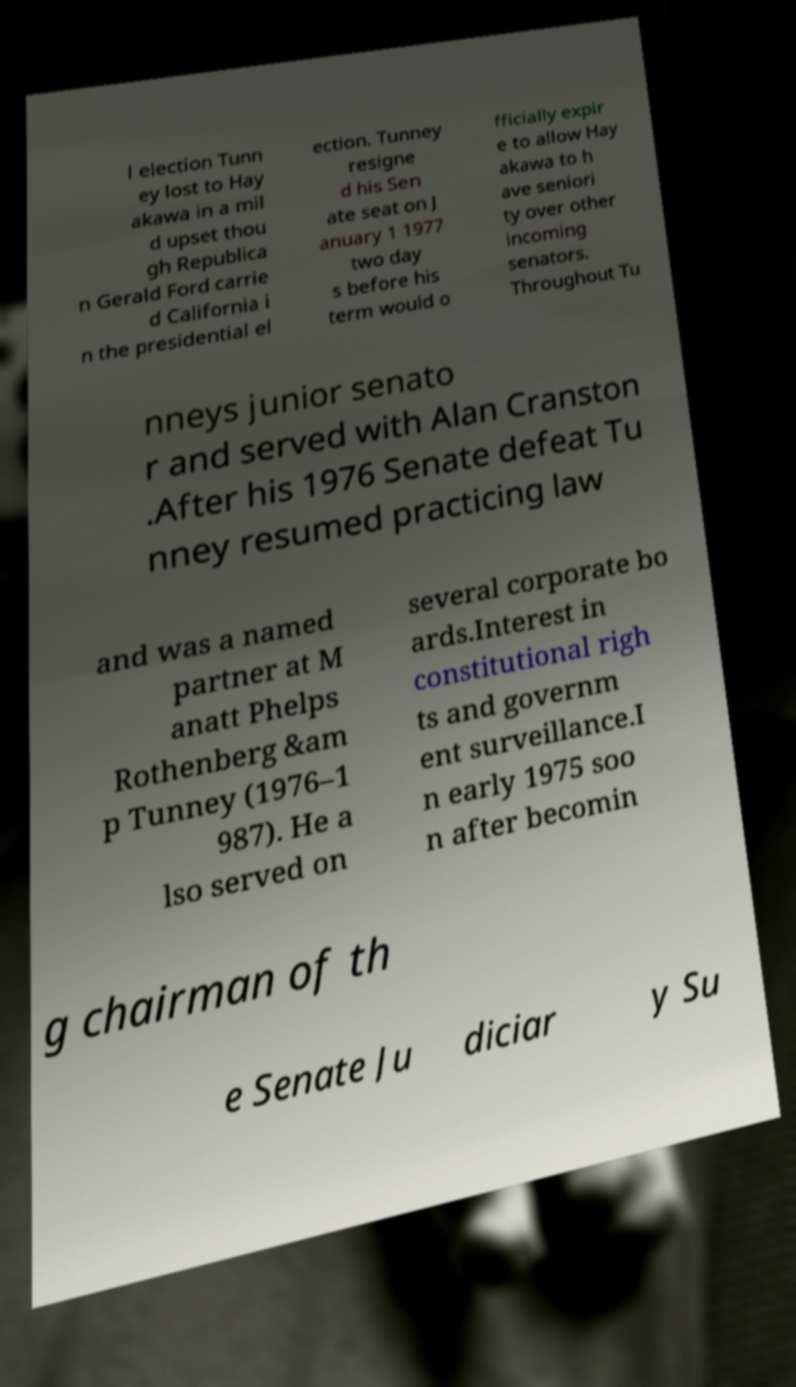I need the written content from this picture converted into text. Can you do that? l election Tunn ey lost to Hay akawa in a mil d upset thou gh Republica n Gerald Ford carrie d California i n the presidential el ection. Tunney resigne d his Sen ate seat on J anuary 1 1977 two day s before his term would o fficially expir e to allow Hay akawa to h ave seniori ty over other incoming senators. Throughout Tu nneys junior senato r and served with Alan Cranston .After his 1976 Senate defeat Tu nney resumed practicing law and was a named partner at M anatt Phelps Rothenberg &am p Tunney (1976–1 987). He a lso served on several corporate bo ards.Interest in constitutional righ ts and governm ent surveillance.I n early 1975 soo n after becomin g chairman of th e Senate Ju diciar y Su 